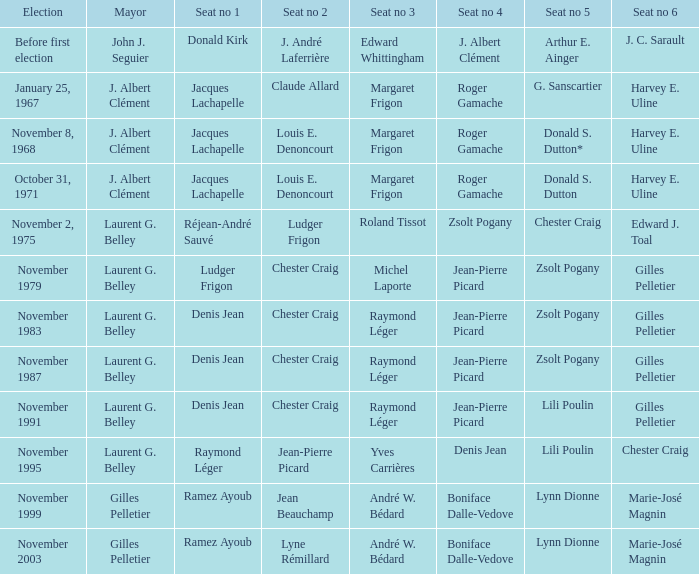Who was the winner of seat no 4 for the election on January 25, 1967 Roger Gamache. 